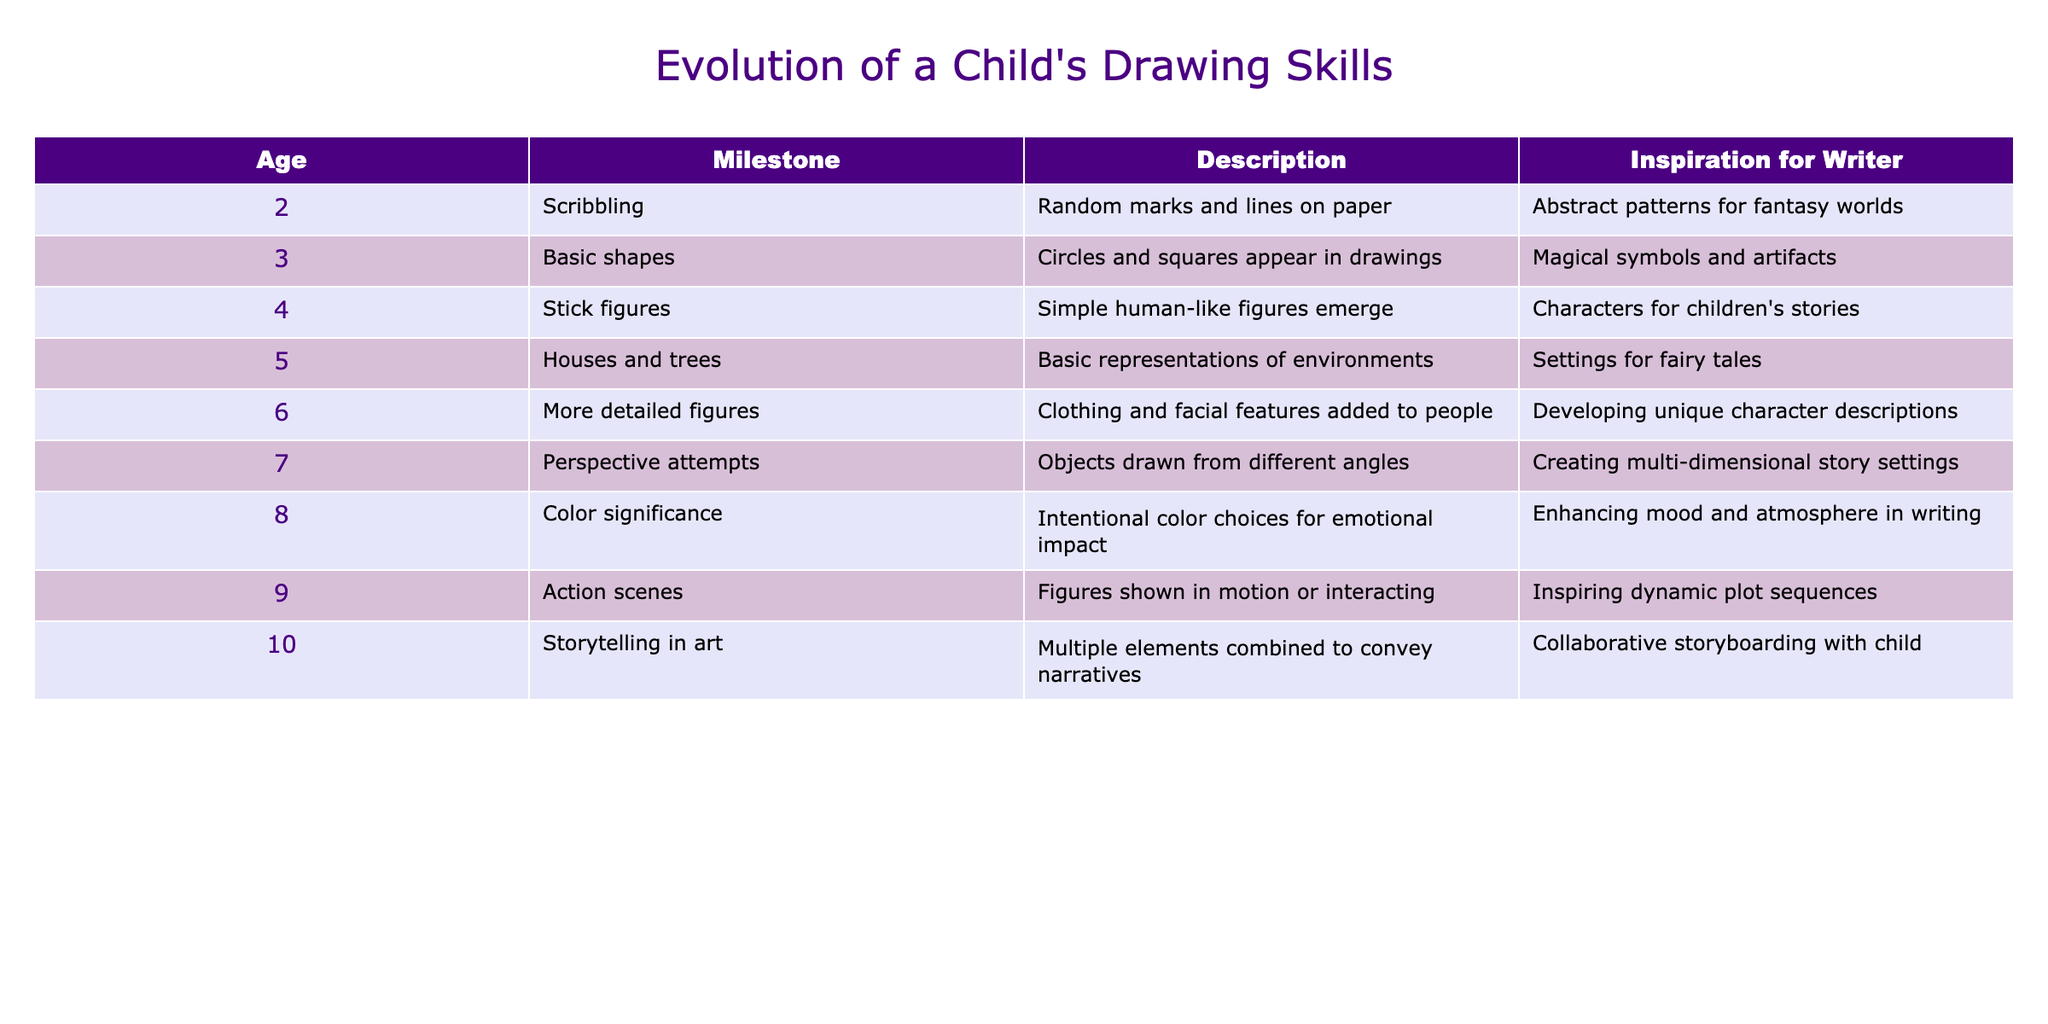What is the milestone achieved at age 6? According to the table, the age 6 milestone is 'More detailed figures', which indicates that children at this age start to add clothing and facial features to their drawings.
Answer: More detailed figures At what age do children start drawing stick figures? The table indicates that children begin to draw stick figures at age 4. This milestone includes simple human-like figures emerging in their artwork.
Answer: Age 4 Which age reflects an attempt at perspective in drawings? The data shows that age 7 reflects attempts at drawing objects from different angles, showcasing children's understanding of perspective in their artwork.
Answer: Age 7 What is the difference between the descriptions of milestones at age 5 and age 9? The milestone description at age 5 is 'Houses and trees', representing basic environmental representations. In contrast, age 9 presents 'Action scenes' where figures are shown in motion or interacting. The difference highlights the progress from static to dynamic illustrations.
Answer: Basic representations vs. dynamic scenes Is there an intentional choice of colors in drawings at age 8? Yes, according to the table, at age 8, children begin to make intentional color choices for emotional impact in their drawings.
Answer: Yes What did the milestone description indicate about children’s artistic abilities between ages 2 and 10? By examining the milestones from ages 2 to 10, one can see a progression from basic scribbling at age 2 to storytelling in art by age 10, which indicates a significant development in both technical skills and narrative comprehension.
Answer: Significant development What are the two milestones that involve interaction in drawings? The milestones that involve interaction in children's drawings are 'Action scenes' at age 9, where figures interact, and 'Storytelling in art' at age 10, where multiple elements convey narratives.
Answer: Action scenes and storytelling in art What age marks the introduction of basic shapes in a child's drawing skills? The table specifies that basic shapes emerge in children's drawings starting at age 3, which is an early developmental milestone in their artistic journey.
Answer: Age 3 At what age is clothing and facial features incorporated into drawings? At age 6, children start incorporating clothing and facial features into their drawings, marking a transition to more detailed representations of figures.
Answer: Age 6 